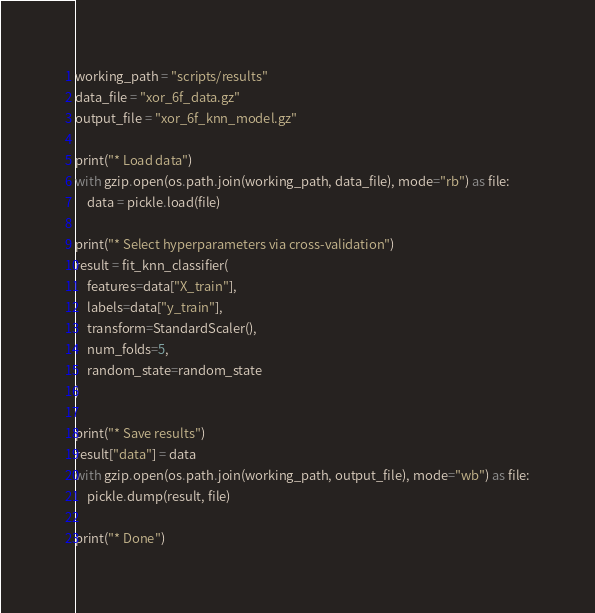Convert code to text. <code><loc_0><loc_0><loc_500><loc_500><_Python_>working_path = "scripts/results"
data_file = "xor_6f_data.gz"
output_file = "xor_6f_knn_model.gz"

print("* Load data")
with gzip.open(os.path.join(working_path, data_file), mode="rb") as file:
    data = pickle.load(file)

print("* Select hyperparameters via cross-validation")
result = fit_knn_classifier(
    features=data["X_train"],
    labels=data["y_train"],
    transform=StandardScaler(),
    num_folds=5,
    random_state=random_state
)

print("* Save results")
result["data"] = data
with gzip.open(os.path.join(working_path, output_file), mode="wb") as file:
    pickle.dump(result, file)

print("* Done")
</code> 